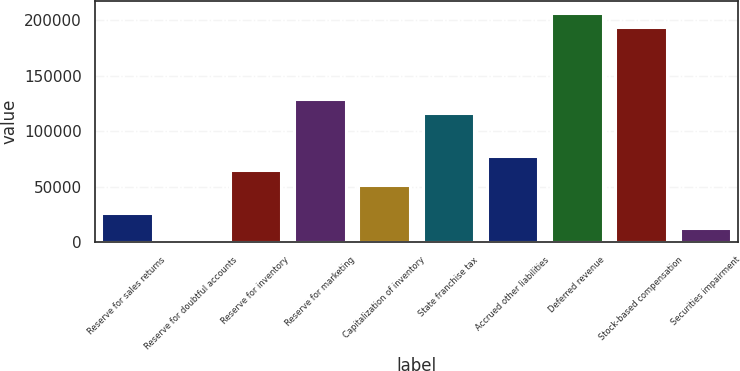Convert chart to OTSL. <chart><loc_0><loc_0><loc_500><loc_500><bar_chart><fcel>Reserve for sales returns<fcel>Reserve for doubtful accounts<fcel>Reserve for inventory<fcel>Reserve for marketing<fcel>Capitalization of inventory<fcel>State franchise tax<fcel>Accrued other liabilities<fcel>Deferred revenue<fcel>Stock-based compensation<fcel>Securities impairment<nl><fcel>25896<fcel>36<fcel>64686<fcel>129336<fcel>51756<fcel>116406<fcel>77616<fcel>206916<fcel>193986<fcel>12966<nl></chart> 